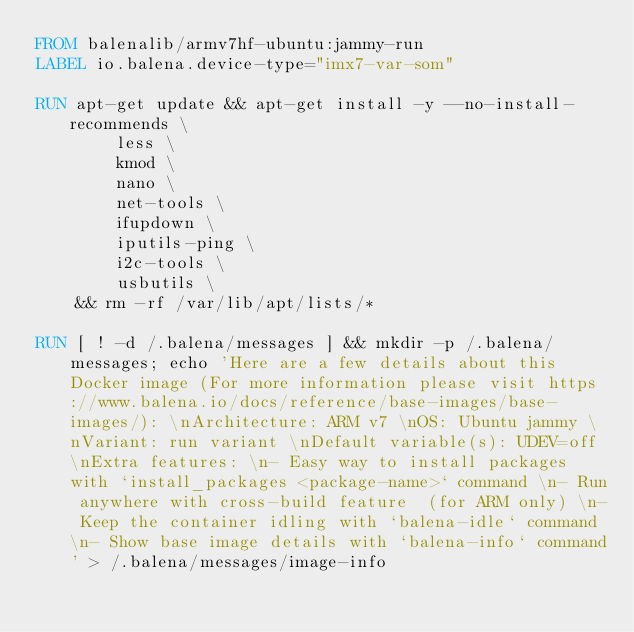Convert code to text. <code><loc_0><loc_0><loc_500><loc_500><_Dockerfile_>FROM balenalib/armv7hf-ubuntu:jammy-run
LABEL io.balena.device-type="imx7-var-som"

RUN apt-get update && apt-get install -y --no-install-recommends \
		less \
		kmod \
		nano \
		net-tools \
		ifupdown \
		iputils-ping \
		i2c-tools \
		usbutils \
	&& rm -rf /var/lib/apt/lists/*

RUN [ ! -d /.balena/messages ] && mkdir -p /.balena/messages; echo 'Here are a few details about this Docker image (For more information please visit https://www.balena.io/docs/reference/base-images/base-images/): \nArchitecture: ARM v7 \nOS: Ubuntu jammy \nVariant: run variant \nDefault variable(s): UDEV=off \nExtra features: \n- Easy way to install packages with `install_packages <package-name>` command \n- Run anywhere with cross-build feature  (for ARM only) \n- Keep the container idling with `balena-idle` command \n- Show base image details with `balena-info` command' > /.balena/messages/image-info</code> 